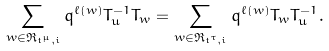Convert formula to latex. <formula><loc_0><loc_0><loc_500><loc_500>\sum _ { w \in \mathfrak { R } _ { \mathfrak { t } ^ { \mu } , i } } q ^ { \ell ( w ) } T _ { u } ^ { - 1 } T _ { w } = \sum _ { w \in \mathfrak { R } _ { \mathfrak { t } ^ { \tau } , i } } q ^ { \ell ( w ) } T _ { w } T _ { u } ^ { - 1 } .</formula> 